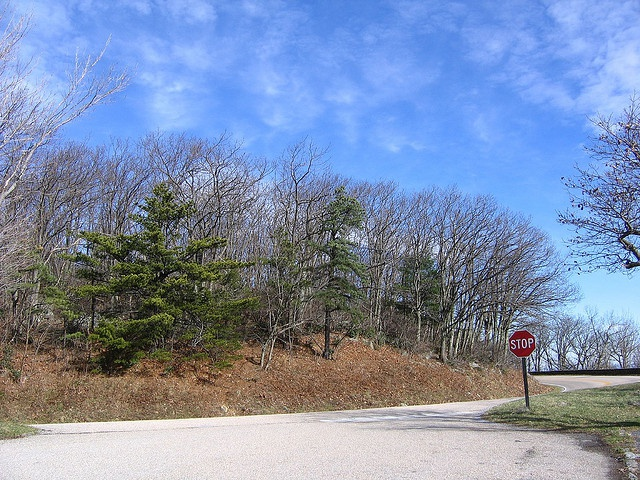Describe the objects in this image and their specific colors. I can see a stop sign in lightblue, maroon, black, darkgray, and lavender tones in this image. 